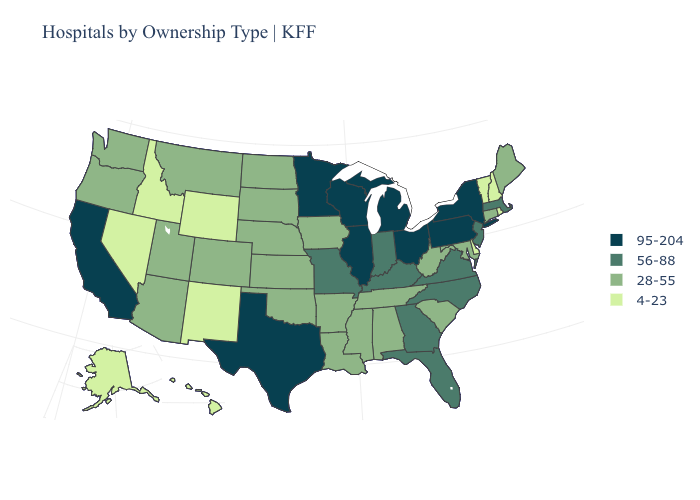What is the lowest value in the USA?
Keep it brief. 4-23. What is the value of New York?
Short answer required. 95-204. What is the lowest value in the Northeast?
Keep it brief. 4-23. Name the states that have a value in the range 28-55?
Keep it brief. Alabama, Arizona, Arkansas, Colorado, Connecticut, Iowa, Kansas, Louisiana, Maine, Maryland, Mississippi, Montana, Nebraska, North Dakota, Oklahoma, Oregon, South Carolina, South Dakota, Tennessee, Utah, Washington, West Virginia. What is the value of Missouri?
Short answer required. 56-88. What is the value of Pennsylvania?
Be succinct. 95-204. Which states have the lowest value in the USA?
Answer briefly. Alaska, Delaware, Hawaii, Idaho, Nevada, New Hampshire, New Mexico, Rhode Island, Vermont, Wyoming. Does Texas have the highest value in the USA?
Keep it brief. Yes. Among the states that border North Dakota , does South Dakota have the lowest value?
Concise answer only. Yes. Which states have the highest value in the USA?
Concise answer only. California, Illinois, Michigan, Minnesota, New York, Ohio, Pennsylvania, Texas, Wisconsin. What is the lowest value in the South?
Write a very short answer. 4-23. What is the highest value in the Northeast ?
Answer briefly. 95-204. Which states have the lowest value in the USA?
Write a very short answer. Alaska, Delaware, Hawaii, Idaho, Nevada, New Hampshire, New Mexico, Rhode Island, Vermont, Wyoming. Does California have the highest value in the West?
Be succinct. Yes. Name the states that have a value in the range 56-88?
Give a very brief answer. Florida, Georgia, Indiana, Kentucky, Massachusetts, Missouri, New Jersey, North Carolina, Virginia. 